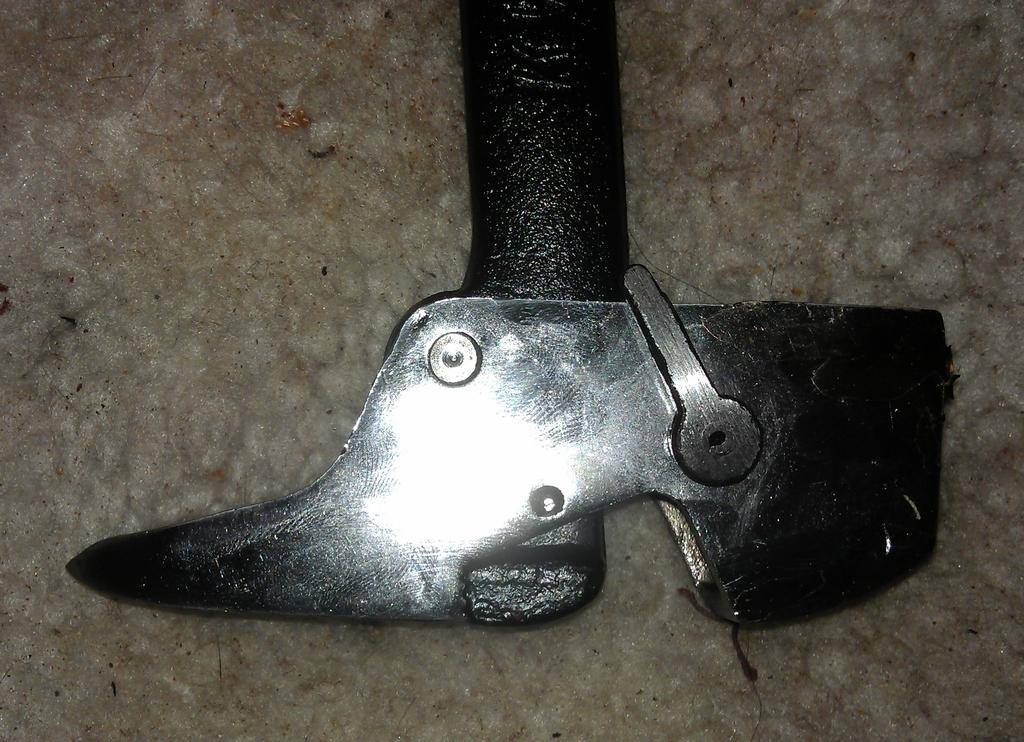What type of material is the object on the floor made of? The object on the floor is made of metal. What type of corn is being cooked on the stove in the image? There is no stove or corn present in the image; it only features a metal object on the floor. 